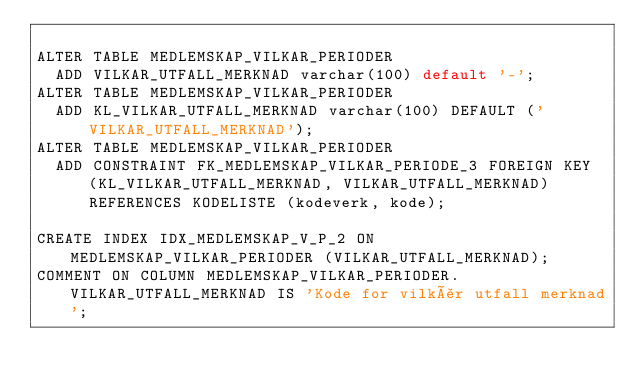<code> <loc_0><loc_0><loc_500><loc_500><_SQL_>
ALTER TABLE MEDLEMSKAP_VILKAR_PERIODER
  ADD VILKAR_UTFALL_MERKNAD varchar(100) default '-';
ALTER TABLE MEDLEMSKAP_VILKAR_PERIODER
  ADD KL_VILKAR_UTFALL_MERKNAD varchar(100) DEFAULT ('VILKAR_UTFALL_MERKNAD');
ALTER TABLE MEDLEMSKAP_VILKAR_PERIODER
  ADD CONSTRAINT FK_MEDLEMSKAP_VILKAR_PERIODE_3 FOREIGN KEY (KL_VILKAR_UTFALL_MERKNAD, VILKAR_UTFALL_MERKNAD) REFERENCES KODELISTE (kodeverk, kode);

CREATE INDEX IDX_MEDLEMSKAP_V_P_2 ON MEDLEMSKAP_VILKAR_PERIODER (VILKAR_UTFALL_MERKNAD);
COMMENT ON COLUMN MEDLEMSKAP_VILKAR_PERIODER.VILKAR_UTFALL_MERKNAD IS 'Kode for vilkår utfall merknad';
</code> 